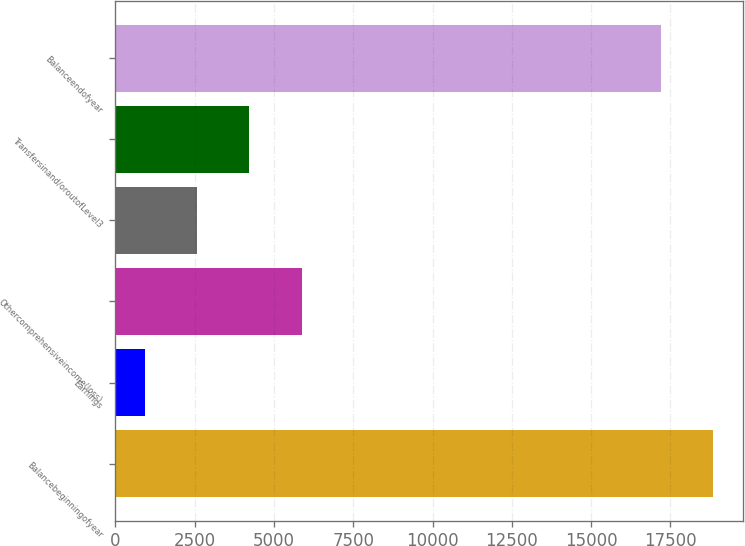Convert chart. <chart><loc_0><loc_0><loc_500><loc_500><bar_chart><fcel>Balancebeginningofyear<fcel>Earnings<fcel>Othercomprehensiveincome(loss)<fcel>Unnamed: 3<fcel>Transfersinand/oroutofLevel3<fcel>Balanceendofyear<nl><fcel>18838.4<fcel>924<fcel>5869.2<fcel>2572.4<fcel>4220.8<fcel>17190<nl></chart> 